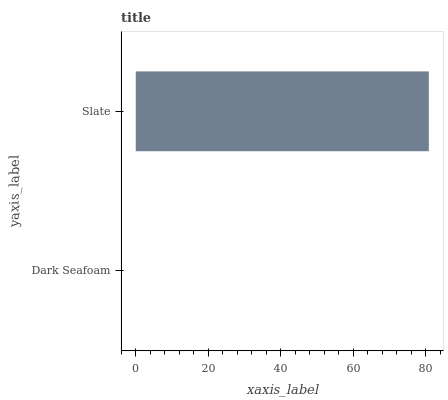Is Dark Seafoam the minimum?
Answer yes or no. Yes. Is Slate the maximum?
Answer yes or no. Yes. Is Slate the minimum?
Answer yes or no. No. Is Slate greater than Dark Seafoam?
Answer yes or no. Yes. Is Dark Seafoam less than Slate?
Answer yes or no. Yes. Is Dark Seafoam greater than Slate?
Answer yes or no. No. Is Slate less than Dark Seafoam?
Answer yes or no. No. Is Slate the high median?
Answer yes or no. Yes. Is Dark Seafoam the low median?
Answer yes or no. Yes. Is Dark Seafoam the high median?
Answer yes or no. No. Is Slate the low median?
Answer yes or no. No. 